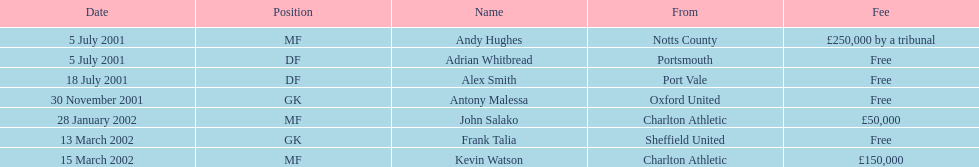Are there a minimum of 2 nationalities displayed on the chart? Yes. 